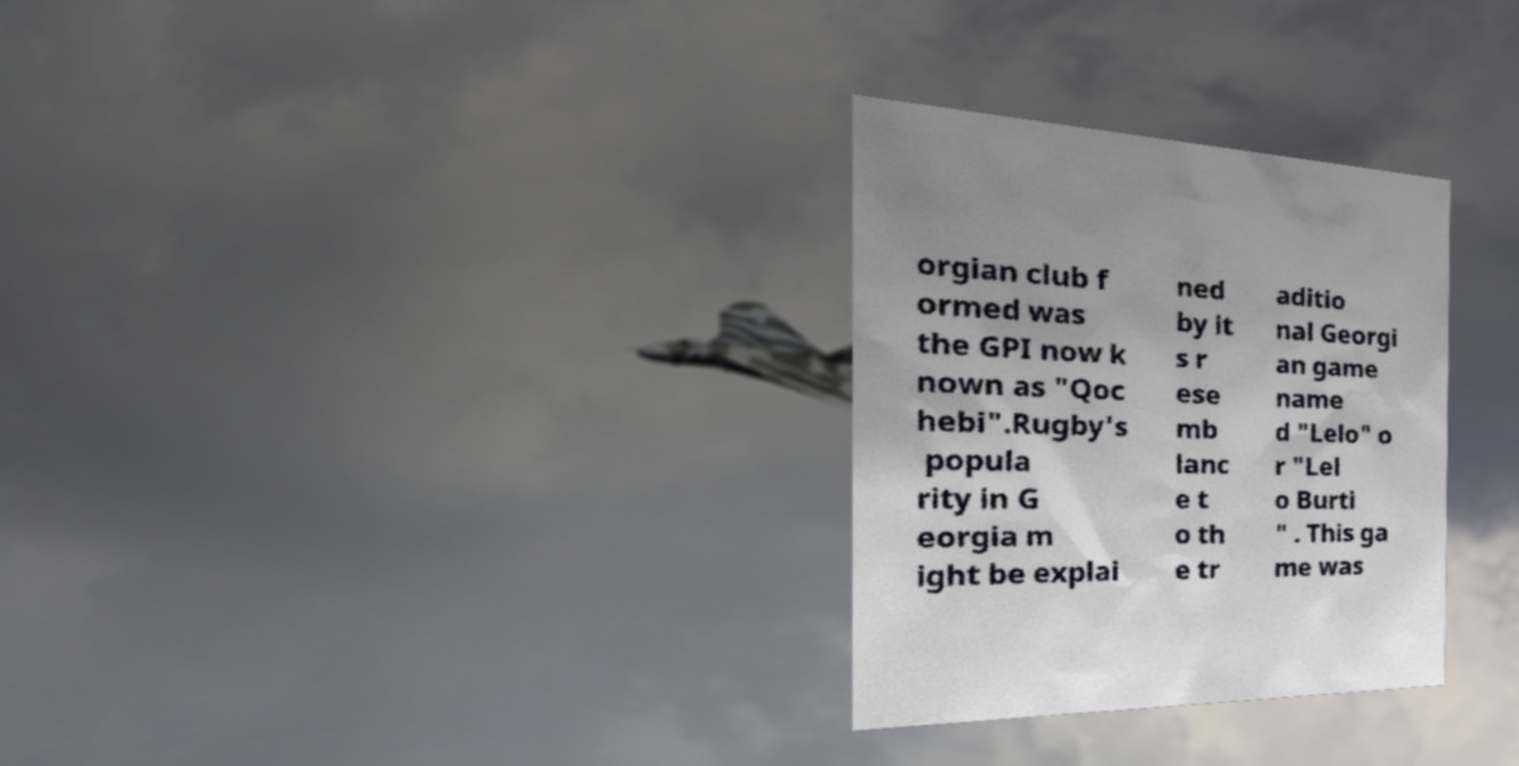Can you read and provide the text displayed in the image?This photo seems to have some interesting text. Can you extract and type it out for me? orgian club f ormed was the GPI now k nown as "Qoc hebi".Rugby's popula rity in G eorgia m ight be explai ned by it s r ese mb lanc e t o th e tr aditio nal Georgi an game name d "Lelo" o r "Lel o Burti " . This ga me was 